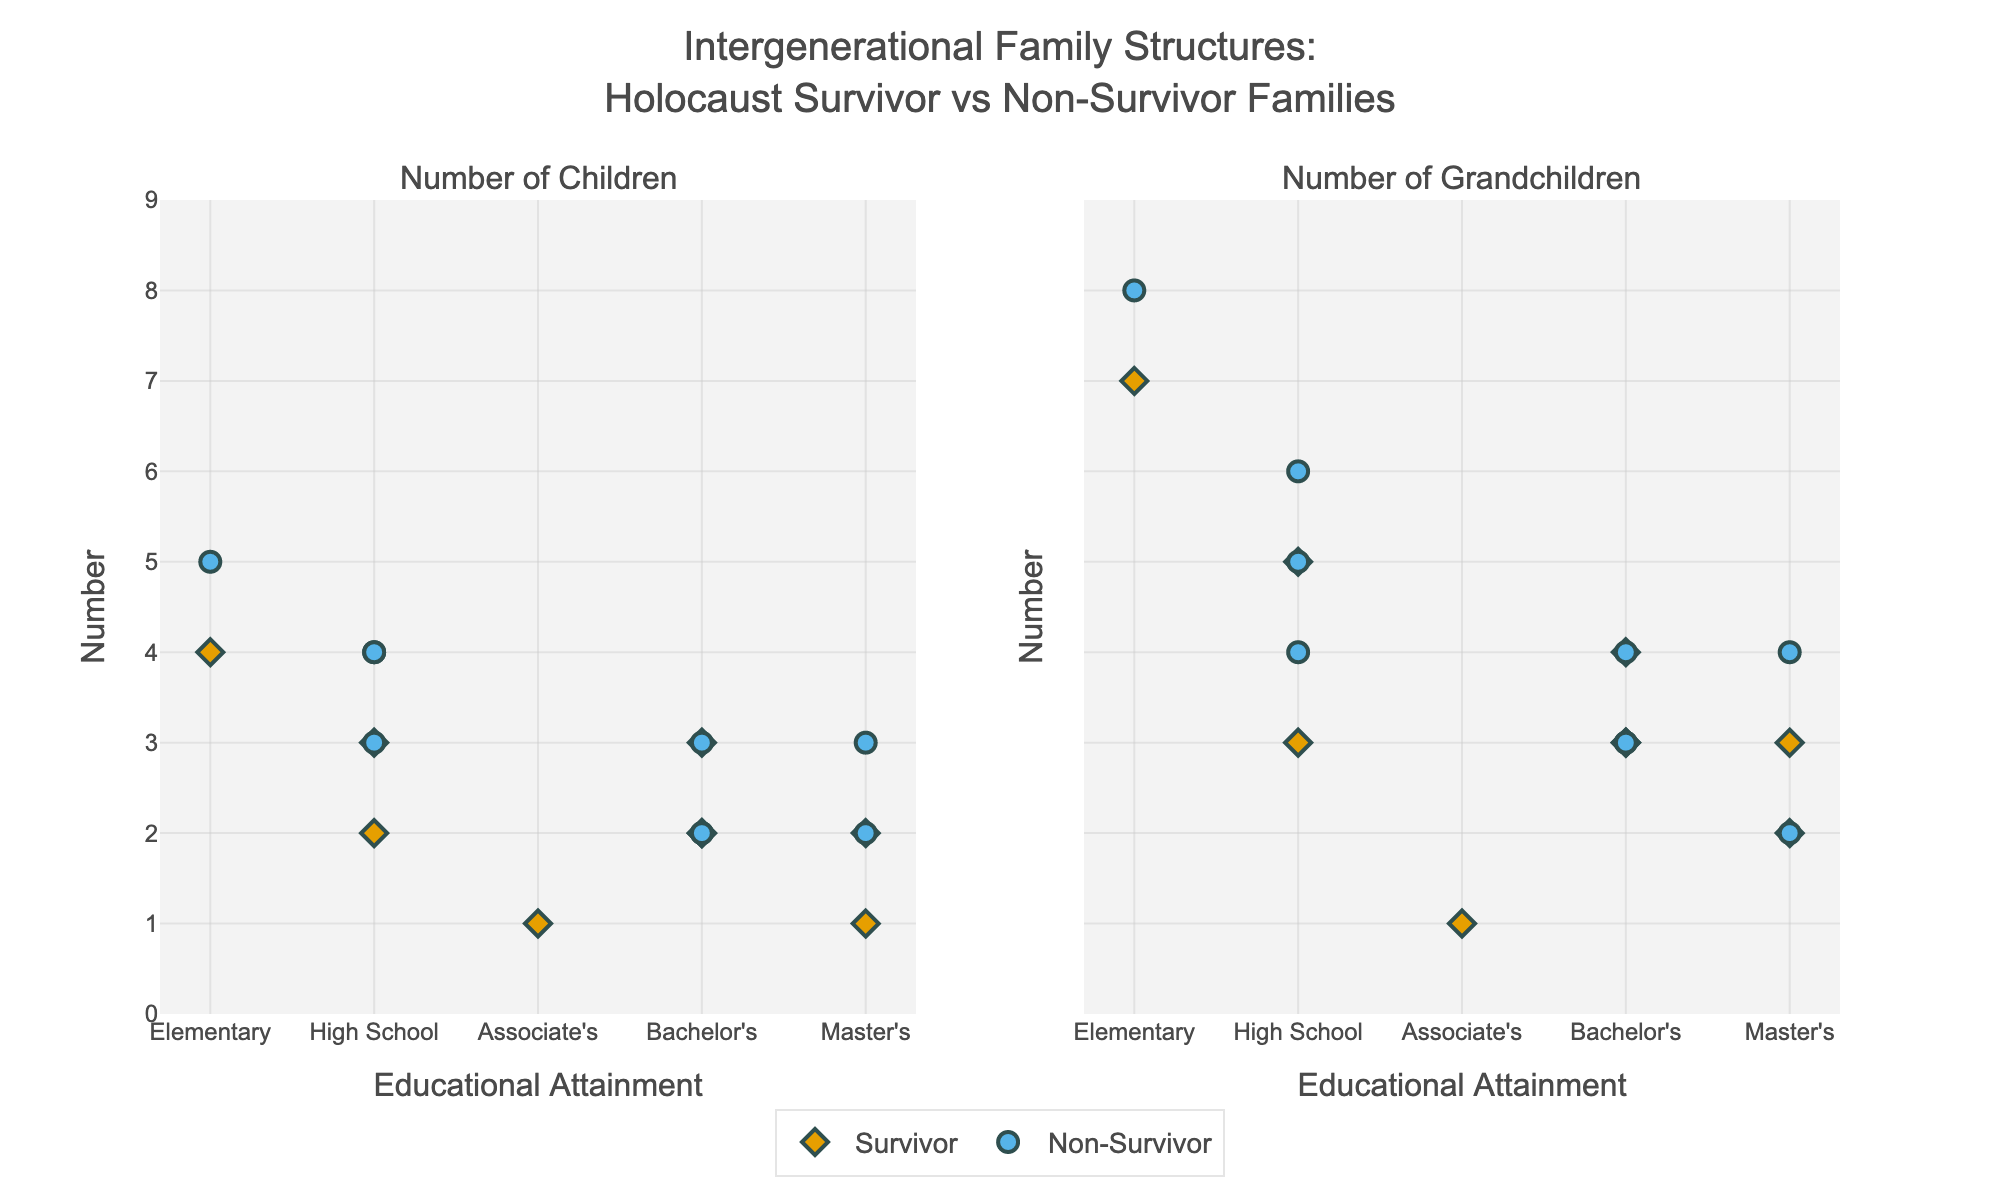what is the title of the plot? The title is usually located at the top center of the plot. It provides an overview of what the plot represents. Here, the title is "Intergenerational Family Structures: Holocaust Survivor vs Non-Survivor Families".
Answer: Intergenerational Family Structures: Holocaust Survivor vs Non-Survivor Families Which group shows a higher number of grandchildren for the first-generation? By visually comparing the number of grandchildren on the y-axis for the first-generation data points, you can identify that 'F2' and 'F6' (both first-generation) have the highest values. F2 (Survivor) has 7, while F6 (Non-Survivor) has 8.
Answer: Non-Survivor What is the educational attainment level of the third generation for the family type with the smallest number of children? Look at the scatter points labeled 'Third' and find the one with the smallest number of children. Then, check the corresponding educational attainment level by noting the x-axis category. The third generation in 'F1' (Survivor) with 1 child has a Master's degree.
Answer: Master's Do survivor families have more children or grandchildren compared to non-survivor families overall? Average the number of children and grandchildren for both survivor and non-survivor families and compare. Survivors have 3+2+2+4+3+2+2 = 18 children, Non-survivors have 3+3+2+4+2+3+5 = 22 children. For grandchildren: Survivors have 5+3+2+7+4+3+3 = 27 grandchildren, Non-survivors have 4+4+3+5+2+4+8=30 grandchildren. Overall non-survivors have more.
Answer: Non-Survivor Which family type exhibits a clearer trend between educational attainment and number of children? By examining the scatter plots for both 'Survivor' and 'Non-Survivor' family types, you can see the correlation. Survivor families show a slight trend with fewer children as educational attainment increases (from 4 children at Elementary School to 1 child at Master's level). The Non-Survivor families also show a similar but less clear trend.
Answer: Survivor In the second generation, which family type has a higher average number of children? Find all the scatter points labeled 'Second' and calculate the averages. Survivor families have 2, 3, and 1 children: (2+3+1)/3 = 2. Non-survivor families have 3, 2, and 4 children: (3+2+4)/3 = 3.
Answer: Non-Survivor Is there any generation where both family types have the same number of average educational attainment levels? From the hover template, compare the educational attainment levels for the 3 generations in both family types. 'Second' generation for both types has an average educational attainment of a Bachelor's degree.
Answer: Second What symbol represents the survivor families in the scatter plot? The figure uses different symbols for survivor and non-survivor families. By looking at the legend or the scatter plot points, you can see that diamonds represent survivor families.
Answer: Diamond 